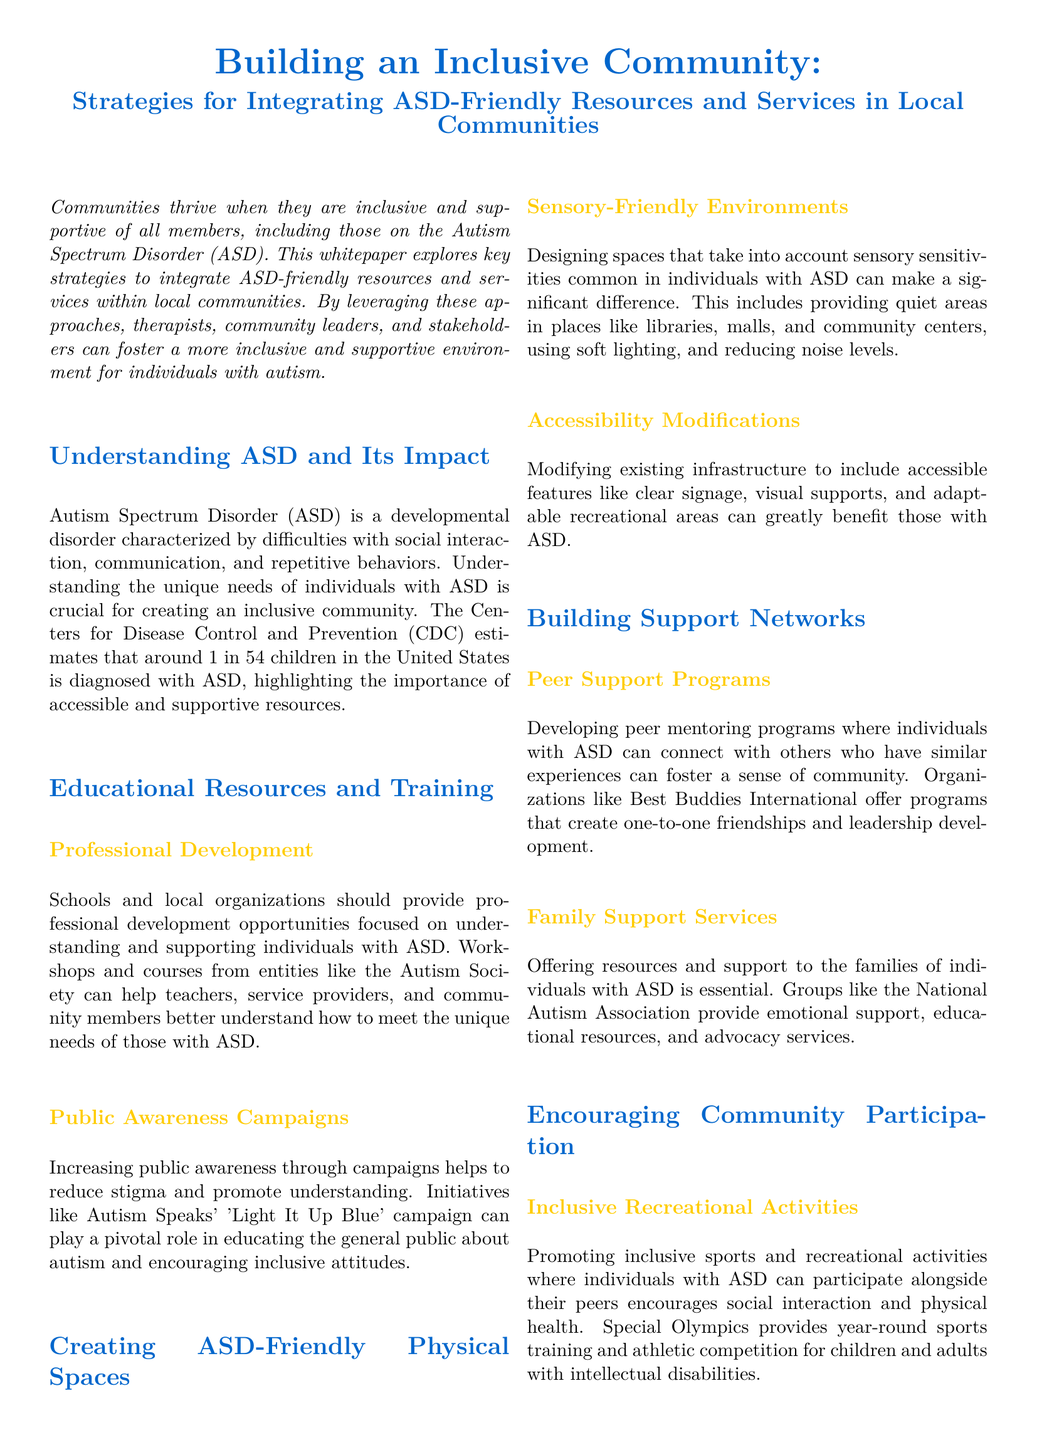what is the estimated prevalence of ASD in the United States? The document cites the CDC estimate indicating that approximately 1 in 54 children is diagnosed with ASD.
Answer: 1 in 54 children which organization offers professional development opportunities for understanding ASD? The document mentions the Autism Society as an entity providing workshops and courses for teachers and service providers.
Answer: Autism Society what is an example of a public awareness campaign mentioned in the paper? The document refers to Autism Speaks' 'Light It Up Blue' campaign as an initiative to promote understanding of autism.
Answer: Light It Up Blue name a type of program that helps individuals with ASD connect with peers. The whitepaper discusses peer mentoring programs which allow individuals with ASD to connect with similar experiences.
Answer: Peer mentoring programs what type of environments are suggested for individuals with ASD? The document advises creating sensory-friendly environments to accommodate sensory sensitivities faced by individuals with ASD.
Answer: Sensory-friendly environments which organization provides year-round sports training for individuals with intellectual disabilities? The whitepaper mentions Special Olympics as an organization that offers sports training and competitions for individuals with ASD.
Answer: Special Olympics what is essential for families of individuals with ASD according to the document? The document emphasizes that offering resources and support to families of individuals with ASD is essential.
Answer: Resources and support what is the primary goal of integrating ASD-friendly resources? The aim outlined in the document is to create an inclusive community that values and integrates individuals with Autism Spectrum Disorder.
Answer: Inclusivity 